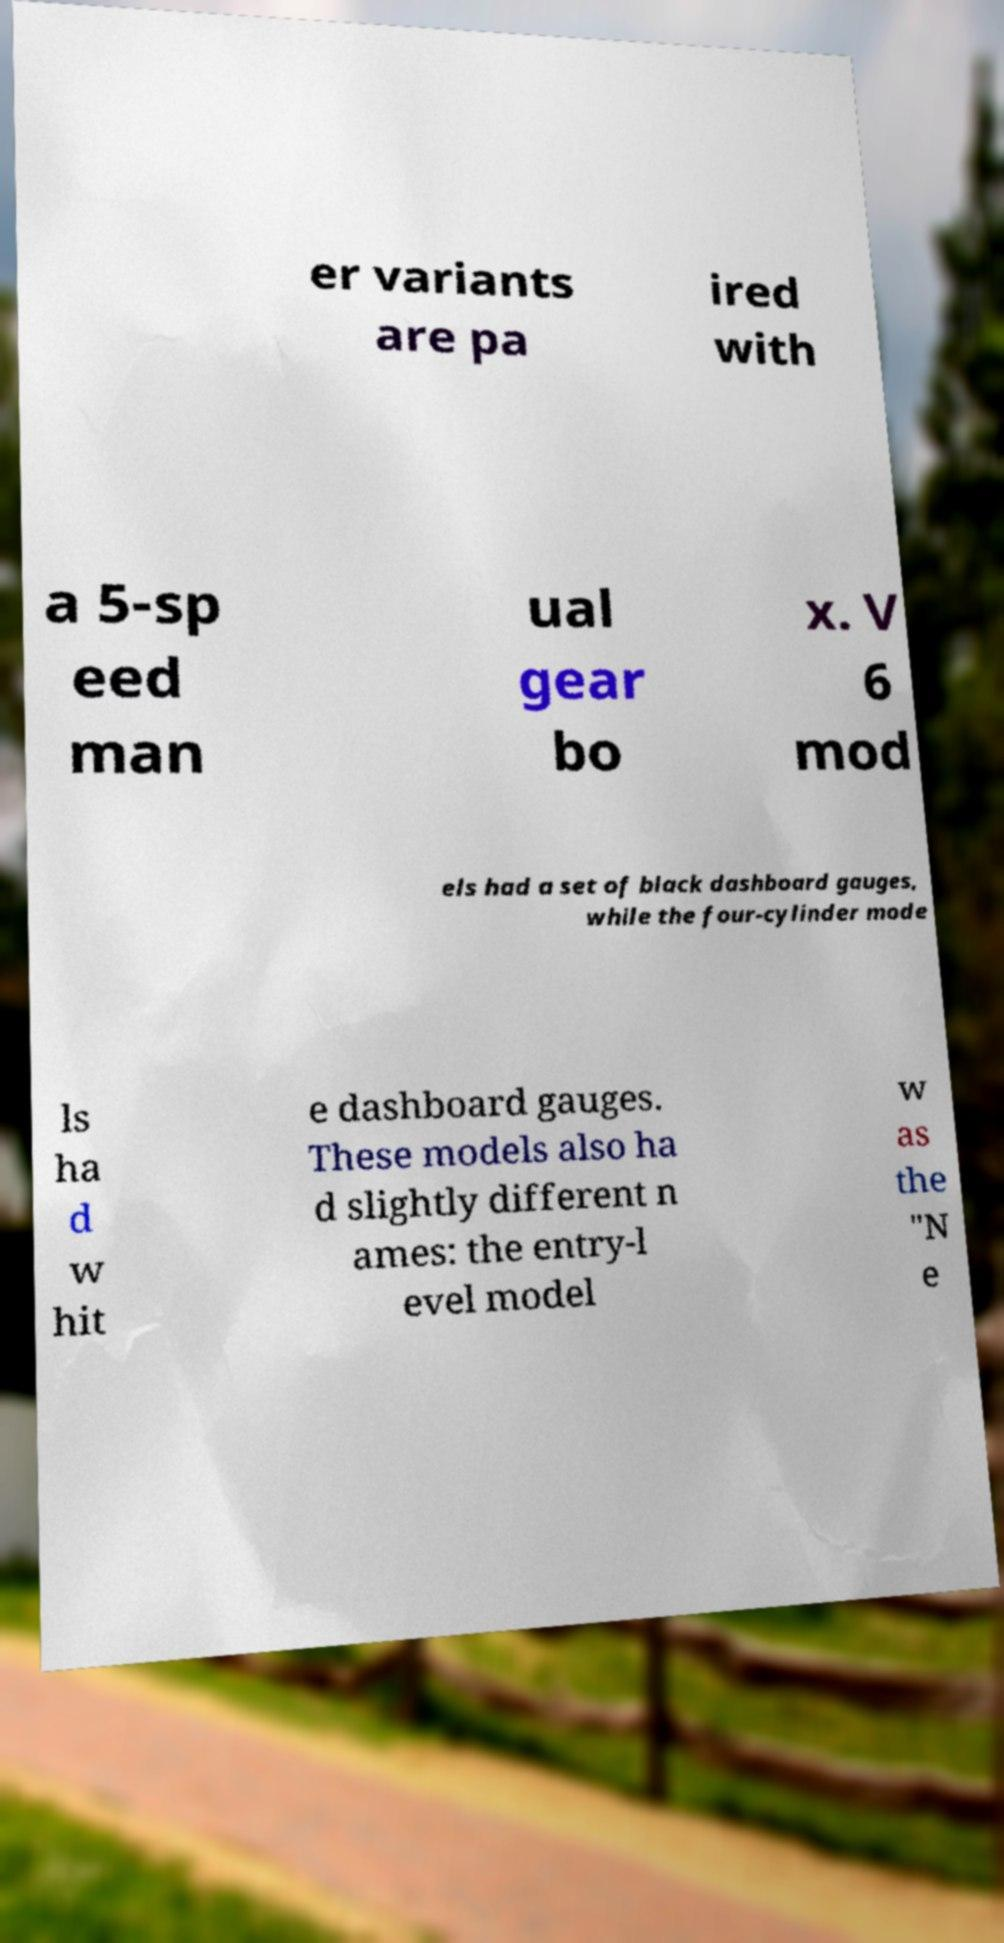For documentation purposes, I need the text within this image transcribed. Could you provide that? er variants are pa ired with a 5-sp eed man ual gear bo x. V 6 mod els had a set of black dashboard gauges, while the four-cylinder mode ls ha d w hit e dashboard gauges. These models also ha d slightly different n ames: the entry-l evel model w as the "N e 